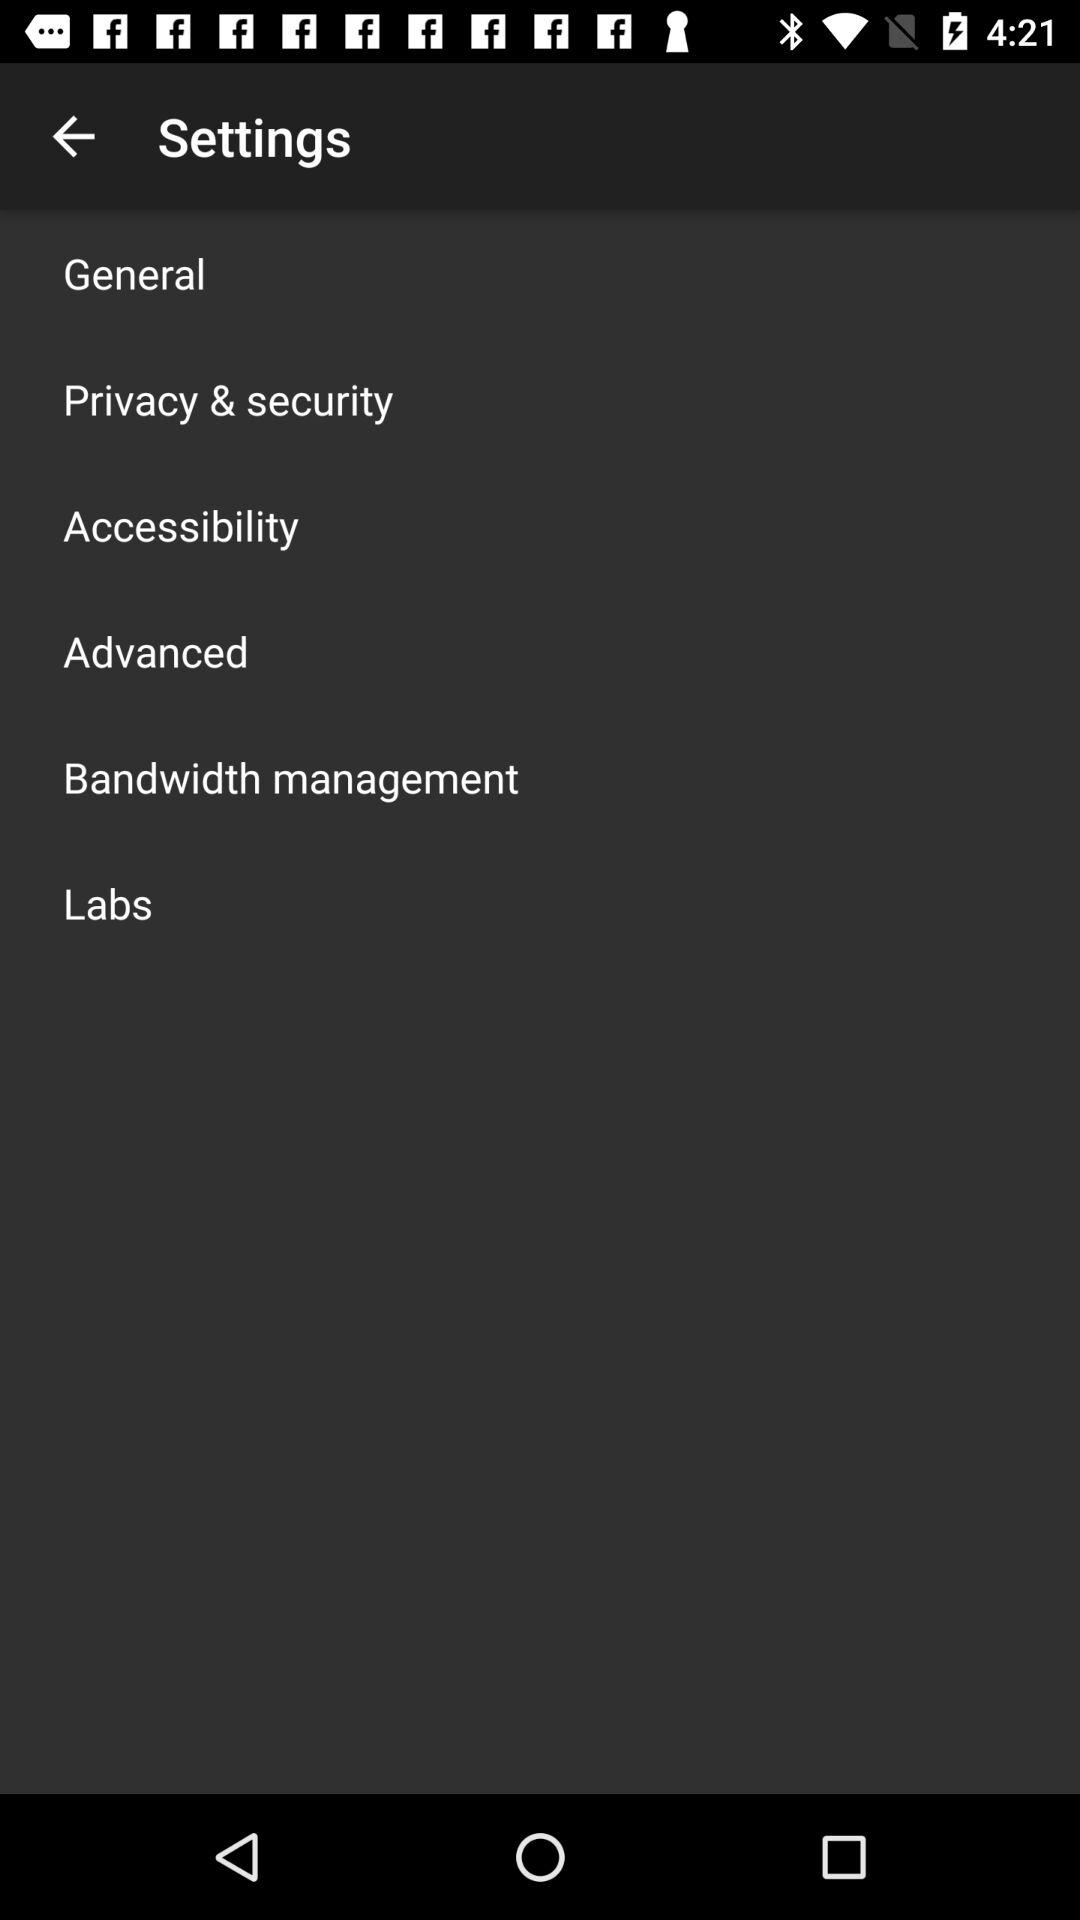How many settings are there in total?
Answer the question using a single word or phrase. 6 